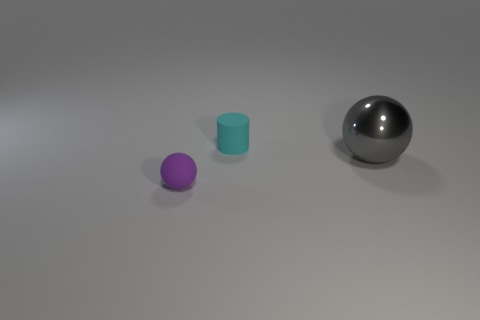Is the size of the cyan rubber cylinder the same as the ball that is behind the rubber sphere?
Provide a short and direct response. No. Is there a ball that has the same color as the matte cylinder?
Keep it short and to the point. No. Is there another rubber object that has the same shape as the tiny cyan object?
Offer a very short reply. No. What shape is the thing that is in front of the tiny cyan object and behind the purple thing?
Give a very brief answer. Sphere. What number of tiny purple balls are made of the same material as the large object?
Make the answer very short. 0. Are there fewer cylinders to the left of the purple thing than big purple rubber things?
Ensure brevity in your answer.  No. Are there any big gray shiny spheres right of the tiny object behind the metallic object?
Offer a very short reply. Yes. Is there anything else that is the same shape as the big object?
Your response must be concise. Yes. Do the purple rubber ball and the matte cylinder have the same size?
Offer a very short reply. Yes. There is a object behind the thing to the right of the matte thing that is behind the gray shiny object; what is its material?
Your answer should be compact. Rubber. 